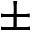Convert formula to latex. <formula><loc_0><loc_0><loc_500><loc_500>\pm</formula> 